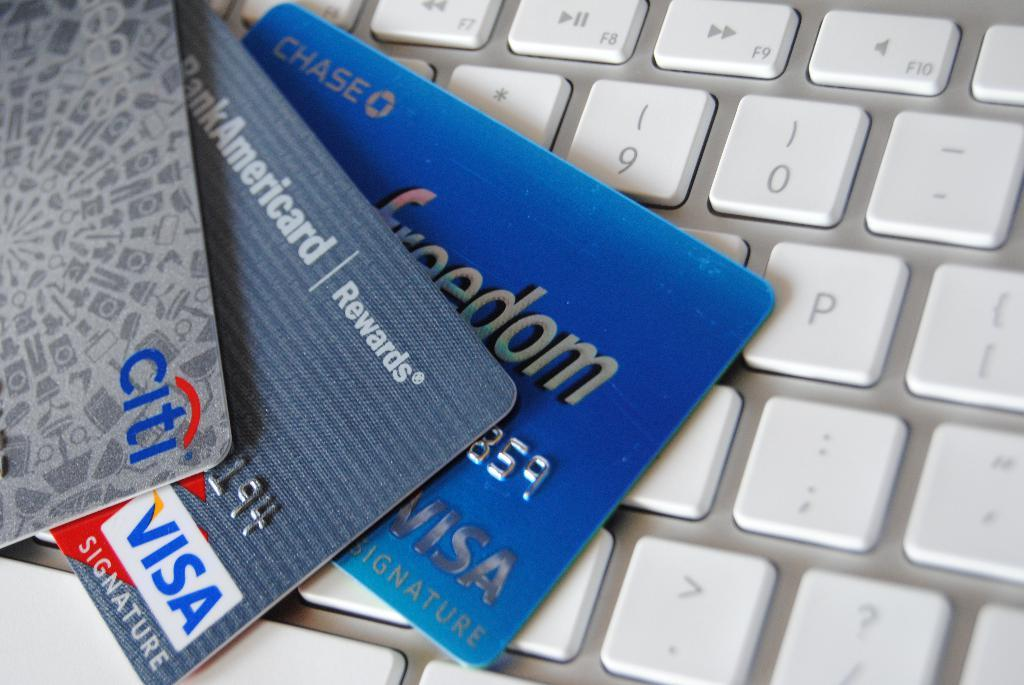<image>
Summarize the visual content of the image. Three cards, including a BankAmericard are on a keyboard. 